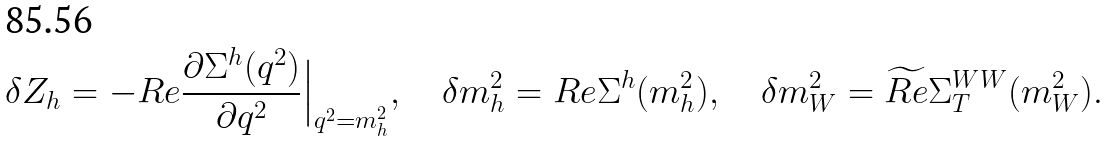Convert formula to latex. <formula><loc_0><loc_0><loc_500><loc_500>\delta Z _ { h } = - R e \frac { \partial \Sigma ^ { h } ( q ^ { 2 } ) } { \partial q ^ { 2 } } \Big { | } _ { q ^ { 2 } = m _ { h } ^ { 2 } } , \quad \delta m _ { h } ^ { 2 } = R e \Sigma ^ { h } ( m _ { h } ^ { 2 } ) , \quad \delta m _ { W } ^ { 2 } = \widetilde { R e } \Sigma _ { T } ^ { W W } ( m _ { W } ^ { 2 } ) .</formula> 